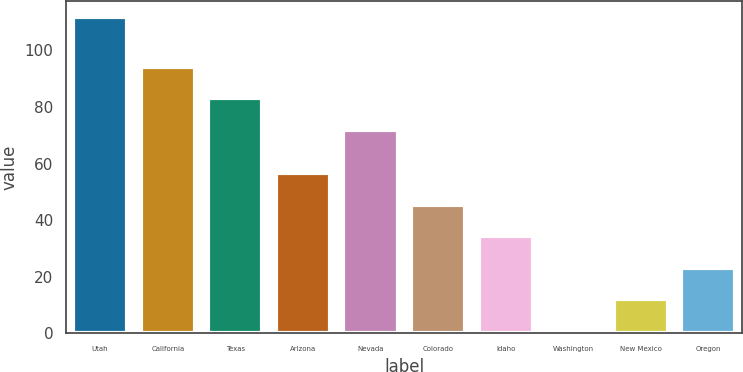Convert chart. <chart><loc_0><loc_0><loc_500><loc_500><bar_chart><fcel>Utah<fcel>California<fcel>Texas<fcel>Arizona<fcel>Nevada<fcel>Colorado<fcel>Idaho<fcel>Washington<fcel>New Mexico<fcel>Oregon<nl><fcel>112<fcel>94.2<fcel>83.1<fcel>56.5<fcel>72<fcel>45.4<fcel>34.3<fcel>1<fcel>12.1<fcel>23.2<nl></chart> 